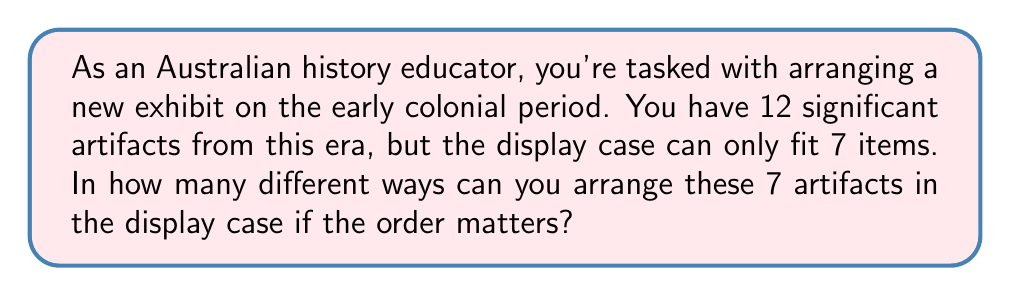Teach me how to tackle this problem. To solve this problem, we need to use the concept of permutations. Permutations are used when the order of selection matters, which is the case for arranging artifacts in a display.

We start with 12 artifacts and need to choose and arrange 7 of them. This scenario is known as a permutation without repetition.

The formula for permutations without repetition is:

$$P(n,r) = \frac{n!}{(n-r)!}$$

Where:
$n$ is the total number of items to choose from
$r$ is the number of items being chosen and arranged

In this case:
$n = 12$ (total artifacts)
$r = 7$ (artifacts to be displayed)

Plugging these values into our formula:

$$P(12,7) = \frac{12!}{(12-7)!} = \frac{12!}{5!}$$

Expanding this:

$$\frac{12 \times 11 \times 10 \times 9 \times 8 \times 7 \times 6 \times 5!}{5!}$$

The $5!$ cancels out in the numerator and denominator:

$$12 \times 11 \times 10 \times 9 \times 8 \times 7 \times 6 = 3,991,680$$

Therefore, there are 3,991,680 different ways to arrange 7 artifacts out of 12 in the display case.
Answer: $3,991,680$ ways 